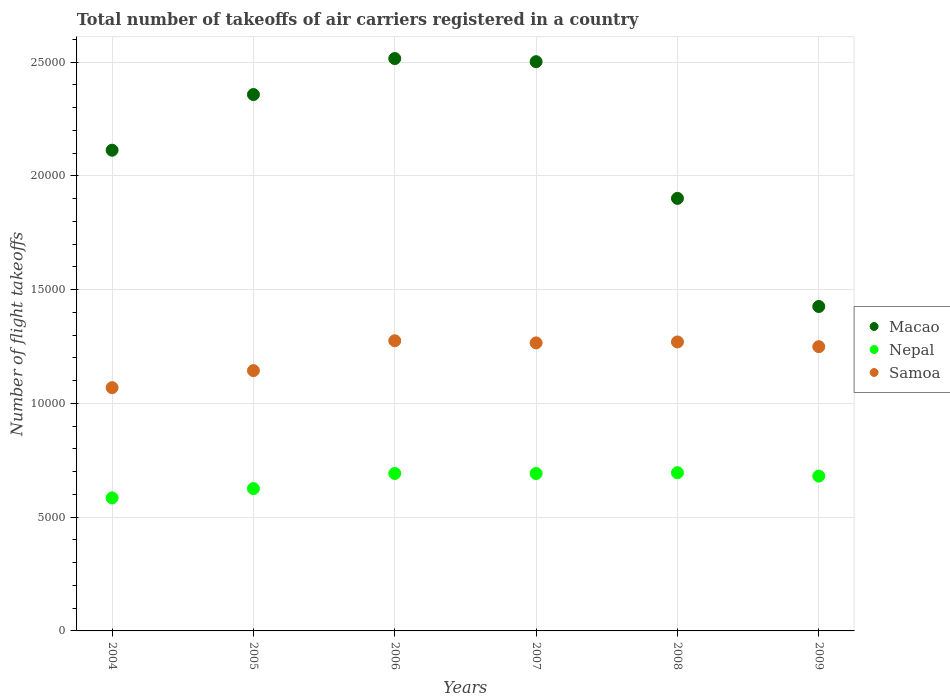How many different coloured dotlines are there?
Make the answer very short. 3. Is the number of dotlines equal to the number of legend labels?
Offer a terse response. Yes. What is the total number of flight takeoffs in Samoa in 2008?
Offer a very short reply. 1.27e+04. Across all years, what is the maximum total number of flight takeoffs in Samoa?
Make the answer very short. 1.28e+04. Across all years, what is the minimum total number of flight takeoffs in Macao?
Provide a succinct answer. 1.43e+04. In which year was the total number of flight takeoffs in Nepal maximum?
Ensure brevity in your answer.  2008. What is the total total number of flight takeoffs in Macao in the graph?
Offer a terse response. 1.28e+05. What is the difference between the total number of flight takeoffs in Nepal in 2004 and that in 2005?
Offer a terse response. -409. What is the difference between the total number of flight takeoffs in Macao in 2006 and the total number of flight takeoffs in Samoa in 2008?
Provide a succinct answer. 1.25e+04. What is the average total number of flight takeoffs in Macao per year?
Provide a succinct answer. 2.14e+04. In the year 2006, what is the difference between the total number of flight takeoffs in Samoa and total number of flight takeoffs in Nepal?
Provide a succinct answer. 5832. In how many years, is the total number of flight takeoffs in Samoa greater than 8000?
Provide a succinct answer. 6. What is the ratio of the total number of flight takeoffs in Macao in 2007 to that in 2008?
Offer a terse response. 1.32. Is the difference between the total number of flight takeoffs in Samoa in 2006 and 2009 greater than the difference between the total number of flight takeoffs in Nepal in 2006 and 2009?
Make the answer very short. Yes. What is the difference between the highest and the second highest total number of flight takeoffs in Nepal?
Your answer should be very brief. 32. What is the difference between the highest and the lowest total number of flight takeoffs in Nepal?
Ensure brevity in your answer.  1106. Is it the case that in every year, the sum of the total number of flight takeoffs in Nepal and total number of flight takeoffs in Samoa  is greater than the total number of flight takeoffs in Macao?
Keep it short and to the point. No. Is the total number of flight takeoffs in Macao strictly greater than the total number of flight takeoffs in Samoa over the years?
Provide a succinct answer. Yes. How many years are there in the graph?
Ensure brevity in your answer.  6. What is the difference between two consecutive major ticks on the Y-axis?
Provide a short and direct response. 5000. Are the values on the major ticks of Y-axis written in scientific E-notation?
Give a very brief answer. No. Does the graph contain grids?
Give a very brief answer. Yes. How many legend labels are there?
Provide a short and direct response. 3. What is the title of the graph?
Your answer should be very brief. Total number of takeoffs of air carriers registered in a country. What is the label or title of the Y-axis?
Make the answer very short. Number of flight takeoffs. What is the Number of flight takeoffs in Macao in 2004?
Give a very brief answer. 2.11e+04. What is the Number of flight takeoffs in Nepal in 2004?
Make the answer very short. 5846. What is the Number of flight takeoffs in Samoa in 2004?
Provide a short and direct response. 1.07e+04. What is the Number of flight takeoffs of Macao in 2005?
Offer a very short reply. 2.36e+04. What is the Number of flight takeoffs of Nepal in 2005?
Your response must be concise. 6255. What is the Number of flight takeoffs in Samoa in 2005?
Give a very brief answer. 1.14e+04. What is the Number of flight takeoffs in Macao in 2006?
Your answer should be very brief. 2.52e+04. What is the Number of flight takeoffs of Nepal in 2006?
Your response must be concise. 6920. What is the Number of flight takeoffs of Samoa in 2006?
Offer a terse response. 1.28e+04. What is the Number of flight takeoffs of Macao in 2007?
Keep it short and to the point. 2.50e+04. What is the Number of flight takeoffs of Nepal in 2007?
Your answer should be compact. 6918. What is the Number of flight takeoffs of Samoa in 2007?
Keep it short and to the point. 1.27e+04. What is the Number of flight takeoffs in Macao in 2008?
Your answer should be compact. 1.90e+04. What is the Number of flight takeoffs in Nepal in 2008?
Your response must be concise. 6952. What is the Number of flight takeoffs of Samoa in 2008?
Provide a short and direct response. 1.27e+04. What is the Number of flight takeoffs of Macao in 2009?
Make the answer very short. 1.43e+04. What is the Number of flight takeoffs of Nepal in 2009?
Ensure brevity in your answer.  6804. What is the Number of flight takeoffs of Samoa in 2009?
Your answer should be very brief. 1.25e+04. Across all years, what is the maximum Number of flight takeoffs of Macao?
Make the answer very short. 2.52e+04. Across all years, what is the maximum Number of flight takeoffs in Nepal?
Provide a succinct answer. 6952. Across all years, what is the maximum Number of flight takeoffs in Samoa?
Ensure brevity in your answer.  1.28e+04. Across all years, what is the minimum Number of flight takeoffs in Macao?
Provide a short and direct response. 1.43e+04. Across all years, what is the minimum Number of flight takeoffs of Nepal?
Your answer should be compact. 5846. Across all years, what is the minimum Number of flight takeoffs of Samoa?
Ensure brevity in your answer.  1.07e+04. What is the total Number of flight takeoffs of Macao in the graph?
Your response must be concise. 1.28e+05. What is the total Number of flight takeoffs in Nepal in the graph?
Offer a terse response. 3.97e+04. What is the total Number of flight takeoffs in Samoa in the graph?
Offer a terse response. 7.27e+04. What is the difference between the Number of flight takeoffs in Macao in 2004 and that in 2005?
Make the answer very short. -2446. What is the difference between the Number of flight takeoffs of Nepal in 2004 and that in 2005?
Your response must be concise. -409. What is the difference between the Number of flight takeoffs in Samoa in 2004 and that in 2005?
Your response must be concise. -748. What is the difference between the Number of flight takeoffs of Macao in 2004 and that in 2006?
Provide a succinct answer. -4028. What is the difference between the Number of flight takeoffs of Nepal in 2004 and that in 2006?
Your answer should be compact. -1074. What is the difference between the Number of flight takeoffs in Samoa in 2004 and that in 2006?
Ensure brevity in your answer.  -2061. What is the difference between the Number of flight takeoffs in Macao in 2004 and that in 2007?
Your answer should be very brief. -3890. What is the difference between the Number of flight takeoffs in Nepal in 2004 and that in 2007?
Make the answer very short. -1072. What is the difference between the Number of flight takeoffs in Samoa in 2004 and that in 2007?
Your answer should be very brief. -1967. What is the difference between the Number of flight takeoffs of Macao in 2004 and that in 2008?
Ensure brevity in your answer.  2117. What is the difference between the Number of flight takeoffs of Nepal in 2004 and that in 2008?
Keep it short and to the point. -1106. What is the difference between the Number of flight takeoffs in Samoa in 2004 and that in 2008?
Give a very brief answer. -2008. What is the difference between the Number of flight takeoffs in Macao in 2004 and that in 2009?
Make the answer very short. 6868. What is the difference between the Number of flight takeoffs of Nepal in 2004 and that in 2009?
Give a very brief answer. -958. What is the difference between the Number of flight takeoffs of Samoa in 2004 and that in 2009?
Make the answer very short. -1801. What is the difference between the Number of flight takeoffs of Macao in 2005 and that in 2006?
Make the answer very short. -1582. What is the difference between the Number of flight takeoffs in Nepal in 2005 and that in 2006?
Your answer should be compact. -665. What is the difference between the Number of flight takeoffs in Samoa in 2005 and that in 2006?
Keep it short and to the point. -1313. What is the difference between the Number of flight takeoffs in Macao in 2005 and that in 2007?
Offer a very short reply. -1444. What is the difference between the Number of flight takeoffs of Nepal in 2005 and that in 2007?
Offer a terse response. -663. What is the difference between the Number of flight takeoffs in Samoa in 2005 and that in 2007?
Offer a terse response. -1219. What is the difference between the Number of flight takeoffs of Macao in 2005 and that in 2008?
Provide a succinct answer. 4563. What is the difference between the Number of flight takeoffs of Nepal in 2005 and that in 2008?
Ensure brevity in your answer.  -697. What is the difference between the Number of flight takeoffs of Samoa in 2005 and that in 2008?
Provide a short and direct response. -1260. What is the difference between the Number of flight takeoffs of Macao in 2005 and that in 2009?
Keep it short and to the point. 9314. What is the difference between the Number of flight takeoffs in Nepal in 2005 and that in 2009?
Ensure brevity in your answer.  -549. What is the difference between the Number of flight takeoffs in Samoa in 2005 and that in 2009?
Give a very brief answer. -1053. What is the difference between the Number of flight takeoffs of Macao in 2006 and that in 2007?
Provide a succinct answer. 138. What is the difference between the Number of flight takeoffs of Nepal in 2006 and that in 2007?
Give a very brief answer. 2. What is the difference between the Number of flight takeoffs in Samoa in 2006 and that in 2007?
Offer a very short reply. 94. What is the difference between the Number of flight takeoffs in Macao in 2006 and that in 2008?
Ensure brevity in your answer.  6145. What is the difference between the Number of flight takeoffs in Nepal in 2006 and that in 2008?
Provide a succinct answer. -32. What is the difference between the Number of flight takeoffs in Samoa in 2006 and that in 2008?
Make the answer very short. 53. What is the difference between the Number of flight takeoffs of Macao in 2006 and that in 2009?
Your answer should be compact. 1.09e+04. What is the difference between the Number of flight takeoffs of Nepal in 2006 and that in 2009?
Your answer should be very brief. 116. What is the difference between the Number of flight takeoffs in Samoa in 2006 and that in 2009?
Offer a very short reply. 260. What is the difference between the Number of flight takeoffs of Macao in 2007 and that in 2008?
Your answer should be very brief. 6007. What is the difference between the Number of flight takeoffs of Nepal in 2007 and that in 2008?
Provide a short and direct response. -34. What is the difference between the Number of flight takeoffs of Samoa in 2007 and that in 2008?
Your answer should be very brief. -41. What is the difference between the Number of flight takeoffs of Macao in 2007 and that in 2009?
Your answer should be very brief. 1.08e+04. What is the difference between the Number of flight takeoffs in Nepal in 2007 and that in 2009?
Your answer should be compact. 114. What is the difference between the Number of flight takeoffs of Samoa in 2007 and that in 2009?
Offer a terse response. 166. What is the difference between the Number of flight takeoffs in Macao in 2008 and that in 2009?
Ensure brevity in your answer.  4751. What is the difference between the Number of flight takeoffs of Nepal in 2008 and that in 2009?
Your answer should be compact. 148. What is the difference between the Number of flight takeoffs of Samoa in 2008 and that in 2009?
Give a very brief answer. 207. What is the difference between the Number of flight takeoffs of Macao in 2004 and the Number of flight takeoffs of Nepal in 2005?
Provide a succinct answer. 1.49e+04. What is the difference between the Number of flight takeoffs of Macao in 2004 and the Number of flight takeoffs of Samoa in 2005?
Your answer should be very brief. 9687. What is the difference between the Number of flight takeoffs of Nepal in 2004 and the Number of flight takeoffs of Samoa in 2005?
Give a very brief answer. -5593. What is the difference between the Number of flight takeoffs of Macao in 2004 and the Number of flight takeoffs of Nepal in 2006?
Offer a terse response. 1.42e+04. What is the difference between the Number of flight takeoffs of Macao in 2004 and the Number of flight takeoffs of Samoa in 2006?
Provide a succinct answer. 8374. What is the difference between the Number of flight takeoffs of Nepal in 2004 and the Number of flight takeoffs of Samoa in 2006?
Keep it short and to the point. -6906. What is the difference between the Number of flight takeoffs in Macao in 2004 and the Number of flight takeoffs in Nepal in 2007?
Keep it short and to the point. 1.42e+04. What is the difference between the Number of flight takeoffs of Macao in 2004 and the Number of flight takeoffs of Samoa in 2007?
Ensure brevity in your answer.  8468. What is the difference between the Number of flight takeoffs of Nepal in 2004 and the Number of flight takeoffs of Samoa in 2007?
Your answer should be compact. -6812. What is the difference between the Number of flight takeoffs in Macao in 2004 and the Number of flight takeoffs in Nepal in 2008?
Your answer should be very brief. 1.42e+04. What is the difference between the Number of flight takeoffs in Macao in 2004 and the Number of flight takeoffs in Samoa in 2008?
Your answer should be compact. 8427. What is the difference between the Number of flight takeoffs in Nepal in 2004 and the Number of flight takeoffs in Samoa in 2008?
Provide a short and direct response. -6853. What is the difference between the Number of flight takeoffs of Macao in 2004 and the Number of flight takeoffs of Nepal in 2009?
Provide a succinct answer. 1.43e+04. What is the difference between the Number of flight takeoffs of Macao in 2004 and the Number of flight takeoffs of Samoa in 2009?
Keep it short and to the point. 8634. What is the difference between the Number of flight takeoffs in Nepal in 2004 and the Number of flight takeoffs in Samoa in 2009?
Ensure brevity in your answer.  -6646. What is the difference between the Number of flight takeoffs of Macao in 2005 and the Number of flight takeoffs of Nepal in 2006?
Ensure brevity in your answer.  1.67e+04. What is the difference between the Number of flight takeoffs of Macao in 2005 and the Number of flight takeoffs of Samoa in 2006?
Offer a very short reply. 1.08e+04. What is the difference between the Number of flight takeoffs in Nepal in 2005 and the Number of flight takeoffs in Samoa in 2006?
Provide a short and direct response. -6497. What is the difference between the Number of flight takeoffs in Macao in 2005 and the Number of flight takeoffs in Nepal in 2007?
Your answer should be very brief. 1.67e+04. What is the difference between the Number of flight takeoffs in Macao in 2005 and the Number of flight takeoffs in Samoa in 2007?
Give a very brief answer. 1.09e+04. What is the difference between the Number of flight takeoffs in Nepal in 2005 and the Number of flight takeoffs in Samoa in 2007?
Offer a very short reply. -6403. What is the difference between the Number of flight takeoffs of Macao in 2005 and the Number of flight takeoffs of Nepal in 2008?
Make the answer very short. 1.66e+04. What is the difference between the Number of flight takeoffs of Macao in 2005 and the Number of flight takeoffs of Samoa in 2008?
Your answer should be very brief. 1.09e+04. What is the difference between the Number of flight takeoffs of Nepal in 2005 and the Number of flight takeoffs of Samoa in 2008?
Your answer should be very brief. -6444. What is the difference between the Number of flight takeoffs in Macao in 2005 and the Number of flight takeoffs in Nepal in 2009?
Offer a very short reply. 1.68e+04. What is the difference between the Number of flight takeoffs in Macao in 2005 and the Number of flight takeoffs in Samoa in 2009?
Your answer should be compact. 1.11e+04. What is the difference between the Number of flight takeoffs of Nepal in 2005 and the Number of flight takeoffs of Samoa in 2009?
Keep it short and to the point. -6237. What is the difference between the Number of flight takeoffs in Macao in 2006 and the Number of flight takeoffs in Nepal in 2007?
Keep it short and to the point. 1.82e+04. What is the difference between the Number of flight takeoffs in Macao in 2006 and the Number of flight takeoffs in Samoa in 2007?
Provide a succinct answer. 1.25e+04. What is the difference between the Number of flight takeoffs of Nepal in 2006 and the Number of flight takeoffs of Samoa in 2007?
Keep it short and to the point. -5738. What is the difference between the Number of flight takeoffs of Macao in 2006 and the Number of flight takeoffs of Nepal in 2008?
Provide a succinct answer. 1.82e+04. What is the difference between the Number of flight takeoffs in Macao in 2006 and the Number of flight takeoffs in Samoa in 2008?
Your answer should be very brief. 1.25e+04. What is the difference between the Number of flight takeoffs in Nepal in 2006 and the Number of flight takeoffs in Samoa in 2008?
Your answer should be compact. -5779. What is the difference between the Number of flight takeoffs in Macao in 2006 and the Number of flight takeoffs in Nepal in 2009?
Your answer should be very brief. 1.84e+04. What is the difference between the Number of flight takeoffs of Macao in 2006 and the Number of flight takeoffs of Samoa in 2009?
Your answer should be very brief. 1.27e+04. What is the difference between the Number of flight takeoffs of Nepal in 2006 and the Number of flight takeoffs of Samoa in 2009?
Keep it short and to the point. -5572. What is the difference between the Number of flight takeoffs in Macao in 2007 and the Number of flight takeoffs in Nepal in 2008?
Ensure brevity in your answer.  1.81e+04. What is the difference between the Number of flight takeoffs in Macao in 2007 and the Number of flight takeoffs in Samoa in 2008?
Give a very brief answer. 1.23e+04. What is the difference between the Number of flight takeoffs of Nepal in 2007 and the Number of flight takeoffs of Samoa in 2008?
Make the answer very short. -5781. What is the difference between the Number of flight takeoffs of Macao in 2007 and the Number of flight takeoffs of Nepal in 2009?
Give a very brief answer. 1.82e+04. What is the difference between the Number of flight takeoffs of Macao in 2007 and the Number of flight takeoffs of Samoa in 2009?
Keep it short and to the point. 1.25e+04. What is the difference between the Number of flight takeoffs of Nepal in 2007 and the Number of flight takeoffs of Samoa in 2009?
Make the answer very short. -5574. What is the difference between the Number of flight takeoffs in Macao in 2008 and the Number of flight takeoffs in Nepal in 2009?
Keep it short and to the point. 1.22e+04. What is the difference between the Number of flight takeoffs of Macao in 2008 and the Number of flight takeoffs of Samoa in 2009?
Ensure brevity in your answer.  6517. What is the difference between the Number of flight takeoffs of Nepal in 2008 and the Number of flight takeoffs of Samoa in 2009?
Provide a succinct answer. -5540. What is the average Number of flight takeoffs of Macao per year?
Keep it short and to the point. 2.14e+04. What is the average Number of flight takeoffs in Nepal per year?
Offer a terse response. 6615.83. What is the average Number of flight takeoffs of Samoa per year?
Keep it short and to the point. 1.21e+04. In the year 2004, what is the difference between the Number of flight takeoffs of Macao and Number of flight takeoffs of Nepal?
Give a very brief answer. 1.53e+04. In the year 2004, what is the difference between the Number of flight takeoffs of Macao and Number of flight takeoffs of Samoa?
Make the answer very short. 1.04e+04. In the year 2004, what is the difference between the Number of flight takeoffs of Nepal and Number of flight takeoffs of Samoa?
Make the answer very short. -4845. In the year 2005, what is the difference between the Number of flight takeoffs in Macao and Number of flight takeoffs in Nepal?
Your answer should be very brief. 1.73e+04. In the year 2005, what is the difference between the Number of flight takeoffs of Macao and Number of flight takeoffs of Samoa?
Your response must be concise. 1.21e+04. In the year 2005, what is the difference between the Number of flight takeoffs in Nepal and Number of flight takeoffs in Samoa?
Your response must be concise. -5184. In the year 2006, what is the difference between the Number of flight takeoffs in Macao and Number of flight takeoffs in Nepal?
Make the answer very short. 1.82e+04. In the year 2006, what is the difference between the Number of flight takeoffs of Macao and Number of flight takeoffs of Samoa?
Make the answer very short. 1.24e+04. In the year 2006, what is the difference between the Number of flight takeoffs of Nepal and Number of flight takeoffs of Samoa?
Keep it short and to the point. -5832. In the year 2007, what is the difference between the Number of flight takeoffs in Macao and Number of flight takeoffs in Nepal?
Your answer should be compact. 1.81e+04. In the year 2007, what is the difference between the Number of flight takeoffs of Macao and Number of flight takeoffs of Samoa?
Make the answer very short. 1.24e+04. In the year 2007, what is the difference between the Number of flight takeoffs in Nepal and Number of flight takeoffs in Samoa?
Ensure brevity in your answer.  -5740. In the year 2008, what is the difference between the Number of flight takeoffs in Macao and Number of flight takeoffs in Nepal?
Offer a very short reply. 1.21e+04. In the year 2008, what is the difference between the Number of flight takeoffs of Macao and Number of flight takeoffs of Samoa?
Your response must be concise. 6310. In the year 2008, what is the difference between the Number of flight takeoffs of Nepal and Number of flight takeoffs of Samoa?
Keep it short and to the point. -5747. In the year 2009, what is the difference between the Number of flight takeoffs in Macao and Number of flight takeoffs in Nepal?
Ensure brevity in your answer.  7454. In the year 2009, what is the difference between the Number of flight takeoffs in Macao and Number of flight takeoffs in Samoa?
Give a very brief answer. 1766. In the year 2009, what is the difference between the Number of flight takeoffs in Nepal and Number of flight takeoffs in Samoa?
Provide a short and direct response. -5688. What is the ratio of the Number of flight takeoffs of Macao in 2004 to that in 2005?
Give a very brief answer. 0.9. What is the ratio of the Number of flight takeoffs in Nepal in 2004 to that in 2005?
Provide a succinct answer. 0.93. What is the ratio of the Number of flight takeoffs of Samoa in 2004 to that in 2005?
Your answer should be compact. 0.93. What is the ratio of the Number of flight takeoffs of Macao in 2004 to that in 2006?
Your answer should be compact. 0.84. What is the ratio of the Number of flight takeoffs of Nepal in 2004 to that in 2006?
Make the answer very short. 0.84. What is the ratio of the Number of flight takeoffs of Samoa in 2004 to that in 2006?
Provide a short and direct response. 0.84. What is the ratio of the Number of flight takeoffs in Macao in 2004 to that in 2007?
Your response must be concise. 0.84. What is the ratio of the Number of flight takeoffs of Nepal in 2004 to that in 2007?
Provide a succinct answer. 0.84. What is the ratio of the Number of flight takeoffs in Samoa in 2004 to that in 2007?
Provide a succinct answer. 0.84. What is the ratio of the Number of flight takeoffs of Macao in 2004 to that in 2008?
Your response must be concise. 1.11. What is the ratio of the Number of flight takeoffs in Nepal in 2004 to that in 2008?
Offer a terse response. 0.84. What is the ratio of the Number of flight takeoffs of Samoa in 2004 to that in 2008?
Provide a short and direct response. 0.84. What is the ratio of the Number of flight takeoffs in Macao in 2004 to that in 2009?
Provide a short and direct response. 1.48. What is the ratio of the Number of flight takeoffs in Nepal in 2004 to that in 2009?
Your answer should be very brief. 0.86. What is the ratio of the Number of flight takeoffs in Samoa in 2004 to that in 2009?
Offer a terse response. 0.86. What is the ratio of the Number of flight takeoffs in Macao in 2005 to that in 2006?
Keep it short and to the point. 0.94. What is the ratio of the Number of flight takeoffs in Nepal in 2005 to that in 2006?
Offer a terse response. 0.9. What is the ratio of the Number of flight takeoffs of Samoa in 2005 to that in 2006?
Offer a terse response. 0.9. What is the ratio of the Number of flight takeoffs of Macao in 2005 to that in 2007?
Your answer should be compact. 0.94. What is the ratio of the Number of flight takeoffs of Nepal in 2005 to that in 2007?
Your response must be concise. 0.9. What is the ratio of the Number of flight takeoffs of Samoa in 2005 to that in 2007?
Keep it short and to the point. 0.9. What is the ratio of the Number of flight takeoffs of Macao in 2005 to that in 2008?
Your answer should be very brief. 1.24. What is the ratio of the Number of flight takeoffs in Nepal in 2005 to that in 2008?
Offer a very short reply. 0.9. What is the ratio of the Number of flight takeoffs of Samoa in 2005 to that in 2008?
Your response must be concise. 0.9. What is the ratio of the Number of flight takeoffs of Macao in 2005 to that in 2009?
Provide a succinct answer. 1.65. What is the ratio of the Number of flight takeoffs of Nepal in 2005 to that in 2009?
Offer a terse response. 0.92. What is the ratio of the Number of flight takeoffs of Samoa in 2005 to that in 2009?
Your response must be concise. 0.92. What is the ratio of the Number of flight takeoffs of Macao in 2006 to that in 2007?
Offer a very short reply. 1.01. What is the ratio of the Number of flight takeoffs of Nepal in 2006 to that in 2007?
Provide a short and direct response. 1. What is the ratio of the Number of flight takeoffs in Samoa in 2006 to that in 2007?
Your answer should be compact. 1.01. What is the ratio of the Number of flight takeoffs of Macao in 2006 to that in 2008?
Keep it short and to the point. 1.32. What is the ratio of the Number of flight takeoffs in Nepal in 2006 to that in 2008?
Offer a very short reply. 1. What is the ratio of the Number of flight takeoffs of Samoa in 2006 to that in 2008?
Provide a short and direct response. 1. What is the ratio of the Number of flight takeoffs in Macao in 2006 to that in 2009?
Your answer should be very brief. 1.76. What is the ratio of the Number of flight takeoffs in Samoa in 2006 to that in 2009?
Provide a succinct answer. 1.02. What is the ratio of the Number of flight takeoffs in Macao in 2007 to that in 2008?
Your answer should be very brief. 1.32. What is the ratio of the Number of flight takeoffs of Samoa in 2007 to that in 2008?
Provide a succinct answer. 1. What is the ratio of the Number of flight takeoffs in Macao in 2007 to that in 2009?
Your response must be concise. 1.75. What is the ratio of the Number of flight takeoffs of Nepal in 2007 to that in 2009?
Your answer should be compact. 1.02. What is the ratio of the Number of flight takeoffs in Samoa in 2007 to that in 2009?
Your response must be concise. 1.01. What is the ratio of the Number of flight takeoffs of Macao in 2008 to that in 2009?
Give a very brief answer. 1.33. What is the ratio of the Number of flight takeoffs of Nepal in 2008 to that in 2009?
Your answer should be compact. 1.02. What is the ratio of the Number of flight takeoffs of Samoa in 2008 to that in 2009?
Make the answer very short. 1.02. What is the difference between the highest and the second highest Number of flight takeoffs in Macao?
Your response must be concise. 138. What is the difference between the highest and the second highest Number of flight takeoffs of Samoa?
Ensure brevity in your answer.  53. What is the difference between the highest and the lowest Number of flight takeoffs of Macao?
Make the answer very short. 1.09e+04. What is the difference between the highest and the lowest Number of flight takeoffs in Nepal?
Your response must be concise. 1106. What is the difference between the highest and the lowest Number of flight takeoffs of Samoa?
Give a very brief answer. 2061. 